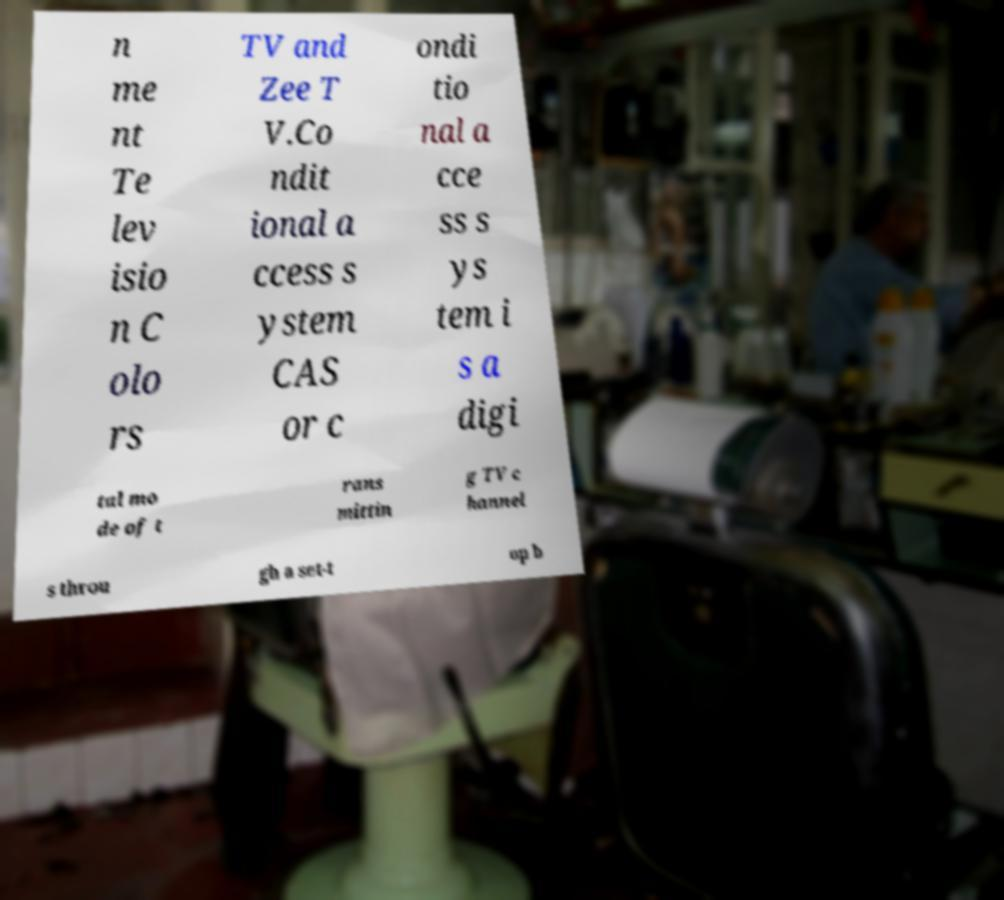What messages or text are displayed in this image? I need them in a readable, typed format. n me nt Te lev isio n C olo rs TV and Zee T V.Co ndit ional a ccess s ystem CAS or c ondi tio nal a cce ss s ys tem i s a digi tal mo de of t rans mittin g TV c hannel s throu gh a set-t op b 